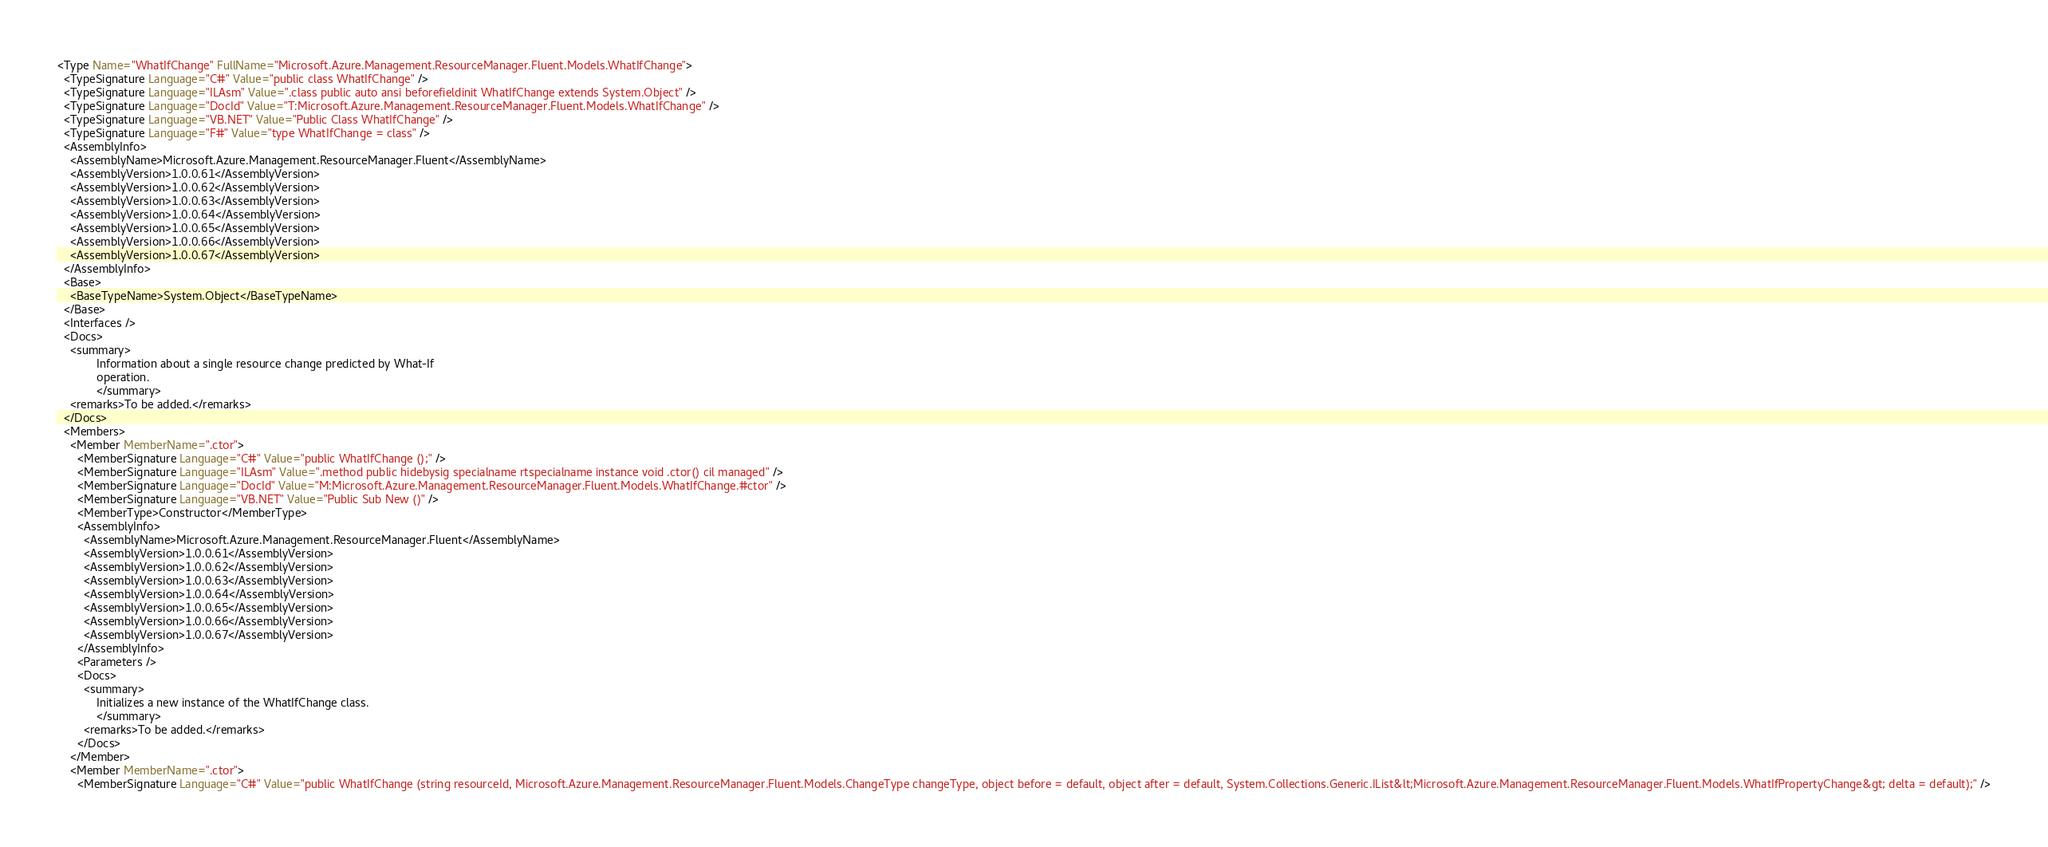Convert code to text. <code><loc_0><loc_0><loc_500><loc_500><_XML_><Type Name="WhatIfChange" FullName="Microsoft.Azure.Management.ResourceManager.Fluent.Models.WhatIfChange">
  <TypeSignature Language="C#" Value="public class WhatIfChange" />
  <TypeSignature Language="ILAsm" Value=".class public auto ansi beforefieldinit WhatIfChange extends System.Object" />
  <TypeSignature Language="DocId" Value="T:Microsoft.Azure.Management.ResourceManager.Fluent.Models.WhatIfChange" />
  <TypeSignature Language="VB.NET" Value="Public Class WhatIfChange" />
  <TypeSignature Language="F#" Value="type WhatIfChange = class" />
  <AssemblyInfo>
    <AssemblyName>Microsoft.Azure.Management.ResourceManager.Fluent</AssemblyName>
    <AssemblyVersion>1.0.0.61</AssemblyVersion>
    <AssemblyVersion>1.0.0.62</AssemblyVersion>
    <AssemblyVersion>1.0.0.63</AssemblyVersion>
    <AssemblyVersion>1.0.0.64</AssemblyVersion>
    <AssemblyVersion>1.0.0.65</AssemblyVersion>
    <AssemblyVersion>1.0.0.66</AssemblyVersion>
    <AssemblyVersion>1.0.0.67</AssemblyVersion>
  </AssemblyInfo>
  <Base>
    <BaseTypeName>System.Object</BaseTypeName>
  </Base>
  <Interfaces />
  <Docs>
    <summary>
            Information about a single resource change predicted by What-If
            operation.
            </summary>
    <remarks>To be added.</remarks>
  </Docs>
  <Members>
    <Member MemberName=".ctor">
      <MemberSignature Language="C#" Value="public WhatIfChange ();" />
      <MemberSignature Language="ILAsm" Value=".method public hidebysig specialname rtspecialname instance void .ctor() cil managed" />
      <MemberSignature Language="DocId" Value="M:Microsoft.Azure.Management.ResourceManager.Fluent.Models.WhatIfChange.#ctor" />
      <MemberSignature Language="VB.NET" Value="Public Sub New ()" />
      <MemberType>Constructor</MemberType>
      <AssemblyInfo>
        <AssemblyName>Microsoft.Azure.Management.ResourceManager.Fluent</AssemblyName>
        <AssemblyVersion>1.0.0.61</AssemblyVersion>
        <AssemblyVersion>1.0.0.62</AssemblyVersion>
        <AssemblyVersion>1.0.0.63</AssemblyVersion>
        <AssemblyVersion>1.0.0.64</AssemblyVersion>
        <AssemblyVersion>1.0.0.65</AssemblyVersion>
        <AssemblyVersion>1.0.0.66</AssemblyVersion>
        <AssemblyVersion>1.0.0.67</AssemblyVersion>
      </AssemblyInfo>
      <Parameters />
      <Docs>
        <summary>
            Initializes a new instance of the WhatIfChange class.
            </summary>
        <remarks>To be added.</remarks>
      </Docs>
    </Member>
    <Member MemberName=".ctor">
      <MemberSignature Language="C#" Value="public WhatIfChange (string resourceId, Microsoft.Azure.Management.ResourceManager.Fluent.Models.ChangeType changeType, object before = default, object after = default, System.Collections.Generic.IList&lt;Microsoft.Azure.Management.ResourceManager.Fluent.Models.WhatIfPropertyChange&gt; delta = default);" /></code> 